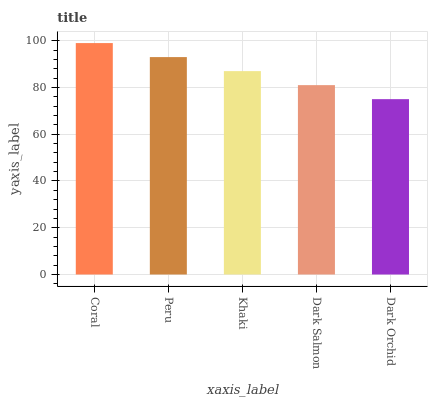Is Dark Orchid the minimum?
Answer yes or no. Yes. Is Coral the maximum?
Answer yes or no. Yes. Is Peru the minimum?
Answer yes or no. No. Is Peru the maximum?
Answer yes or no. No. Is Coral greater than Peru?
Answer yes or no. Yes. Is Peru less than Coral?
Answer yes or no. Yes. Is Peru greater than Coral?
Answer yes or no. No. Is Coral less than Peru?
Answer yes or no. No. Is Khaki the high median?
Answer yes or no. Yes. Is Khaki the low median?
Answer yes or no. Yes. Is Dark Salmon the high median?
Answer yes or no. No. Is Dark Orchid the low median?
Answer yes or no. No. 